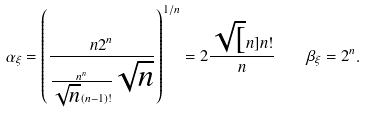Convert formula to latex. <formula><loc_0><loc_0><loc_500><loc_500>\alpha _ { \xi } = \left ( \frac { n 2 ^ { n } } { \frac { n ^ { n } } { \sqrt { n } ( n - 1 ) ! } \sqrt { n } } \right ) ^ { 1 / n } = 2 \frac { \sqrt { [ } n ] { n ! } } { n } \quad \beta _ { \xi } = 2 ^ { n } .</formula> 